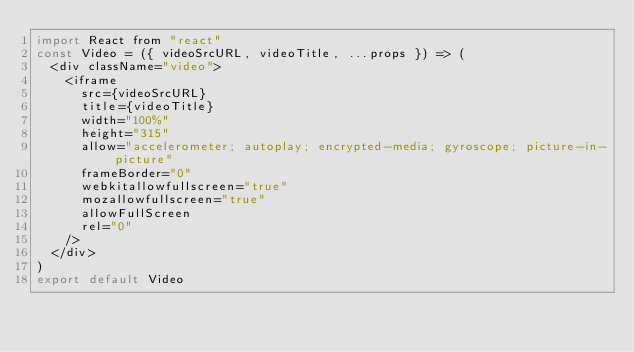Convert code to text. <code><loc_0><loc_0><loc_500><loc_500><_JavaScript_>import React from "react"
const Video = ({ videoSrcURL, videoTitle, ...props }) => (
  <div className="video">
    <iframe
      src={videoSrcURL}
      title={videoTitle}
      width="100%"
      height="315"
      allow="accelerometer; autoplay; encrypted-media; gyroscope; picture-in-picture"
      frameBorder="0"
      webkitallowfullscreen="true"
      mozallowfullscreen="true"
      allowFullScreen
      rel="0"
    />
  </div>
)
export default Video

</code> 